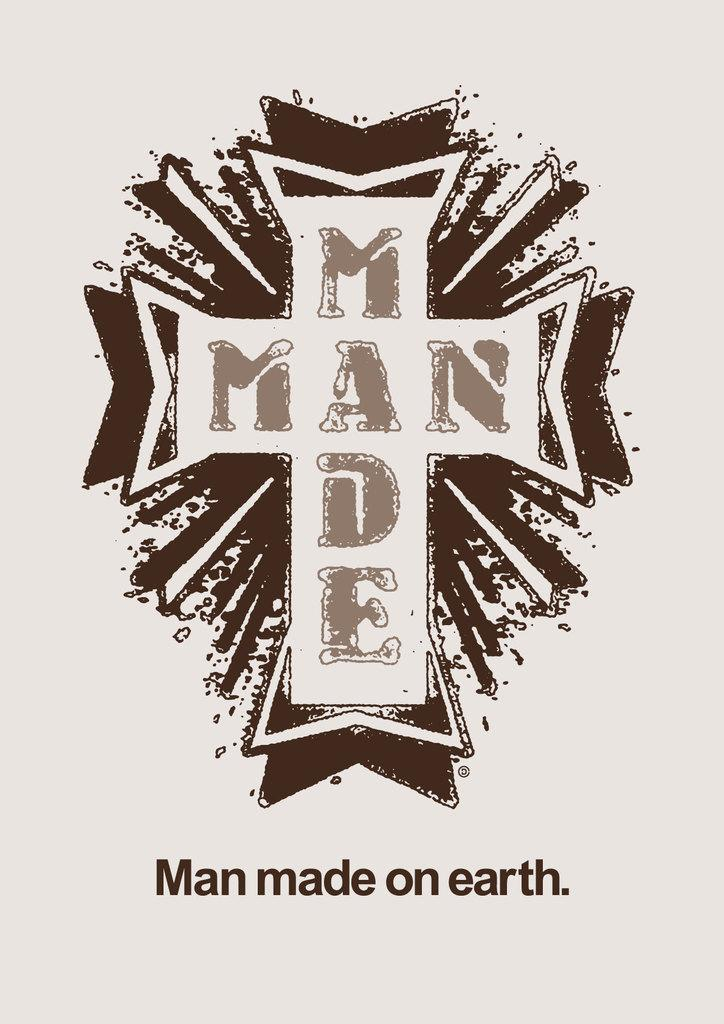<image>
Create a compact narrative representing the image presented. A cross with the words "Man Made" on the front and "Man Made on Earth" printed below the cross. 